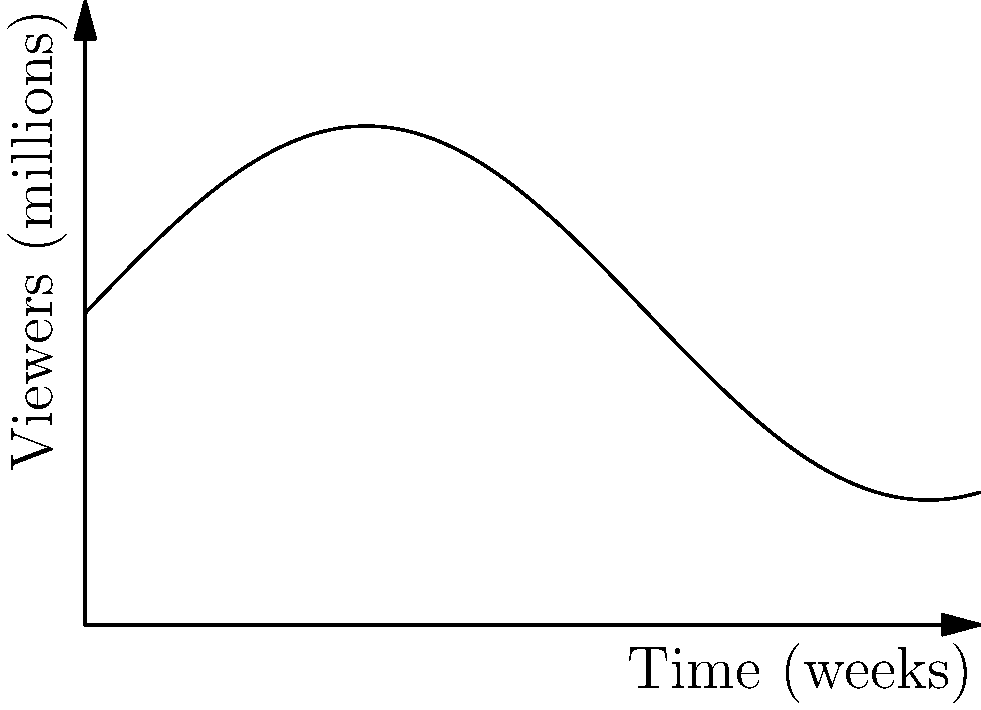As a television show producer in Russia, you're analyzing the viewership of a new series. The graph shows the number of viewers (in millions) over the first 10 weeks. At which point during this period is the rate of change in viewership the highest? To find the point with the highest rate of change in viewership, we need to identify where the slope of the curve is steepest. Let's analyze the graph step-by-step:

1. The viewership is represented by the function $f(x) = 5 + 3\sin(x/2)$, where $x$ is time in weeks.

2. The rate of change is given by the derivative: $f'(x) = \frac{3}{2}\cos(x/2)$.

3. The maximum rate of change occurs where $f'(x)$ is at its maximum value.

4. $\cos(x/2)$ reaches its maximum value of 1 when $x/2 = 2\pi n$, where $n$ is an integer.

5. In the given 10-week period, this occurs when $x/2 = 0$, or $x = 0$.

6. This corresponds to the beginning of the graph, at week 0.

7. Visually, we can confirm this by observing that the curve is steepest (has the highest positive slope) at the left edge of the graph.

Therefore, the rate of change in viewership is highest at the very beginning of the 10-week period.
Answer: Week 0 